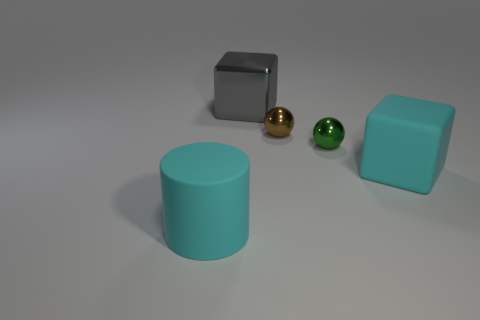Add 5 cyan rubber blocks. How many objects exist? 10 Subtract all blocks. How many objects are left? 3 Add 1 cyan rubber blocks. How many cyan rubber blocks are left? 2 Add 2 large cyan cylinders. How many large cyan cylinders exist? 3 Subtract 0 blue spheres. How many objects are left? 5 Subtract all large metal cubes. Subtract all big gray objects. How many objects are left? 3 